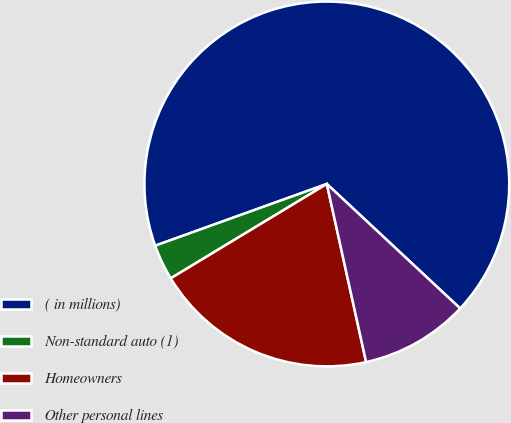<chart> <loc_0><loc_0><loc_500><loc_500><pie_chart><fcel>( in millions)<fcel>Non-standard auto (1)<fcel>Homeowners<fcel>Other personal lines<nl><fcel>67.45%<fcel>3.16%<fcel>19.8%<fcel>9.59%<nl></chart> 